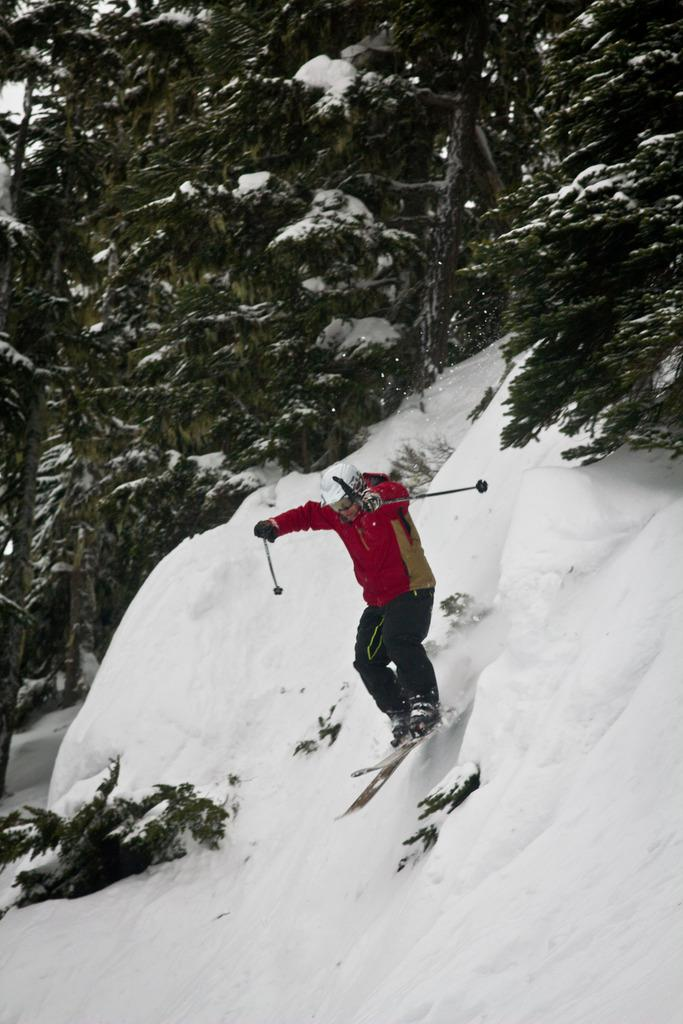What is the main subject of the image? There is a person in the image. What is the person doing in the image? The person is on a skateboard. What is the person holding in the image? The person is holding some objects. What can be seen in the background of the image? There is snow and trees visible in the background of the image. What type of lunch is the person eating while on the skateboard in the image? There is no indication in the image that the person is eating lunch, so it cannot be determined from the picture. 